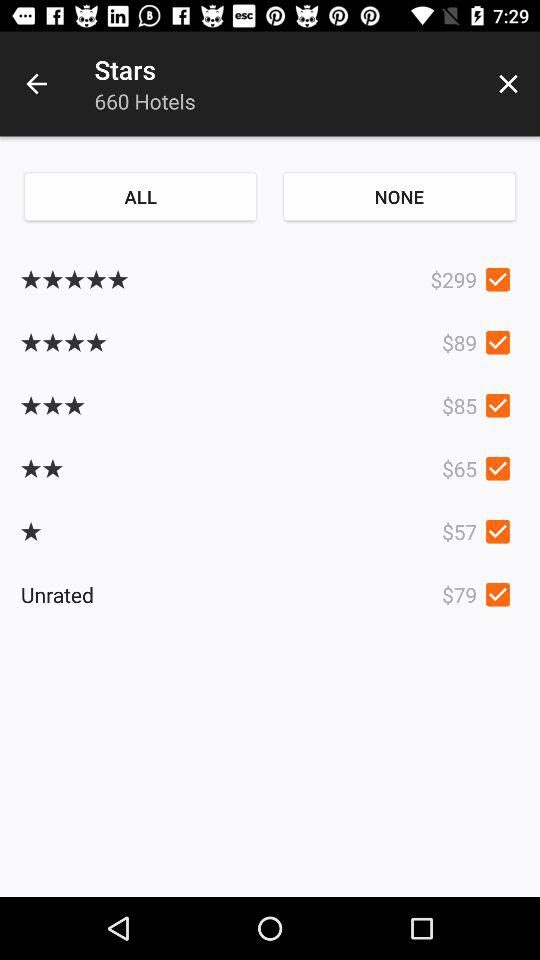What is the rate of the unrated? The rate is $79. 